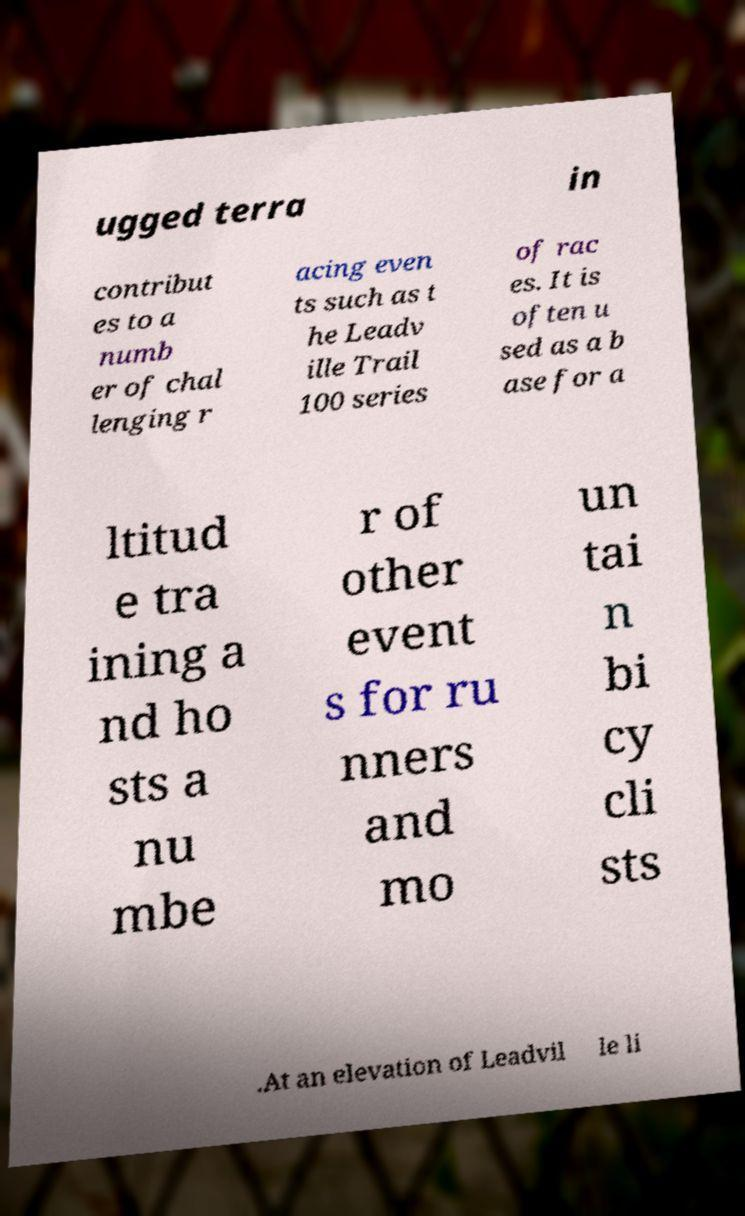Can you read and provide the text displayed in the image?This photo seems to have some interesting text. Can you extract and type it out for me? ugged terra in contribut es to a numb er of chal lenging r acing even ts such as t he Leadv ille Trail 100 series of rac es. It is often u sed as a b ase for a ltitud e tra ining a nd ho sts a nu mbe r of other event s for ru nners and mo un tai n bi cy cli sts .At an elevation of Leadvil le li 